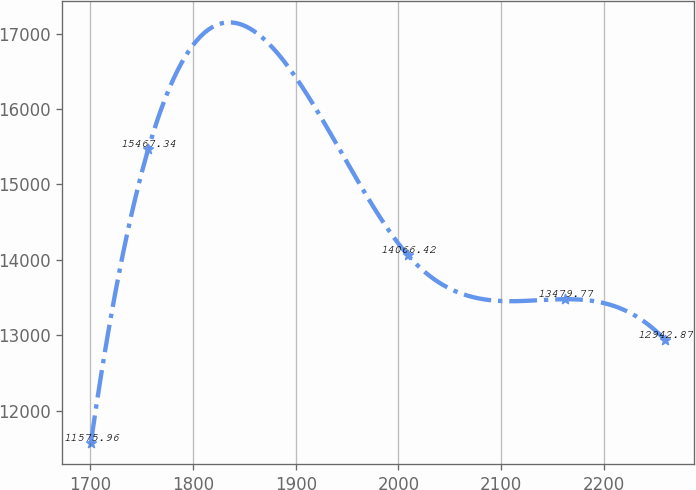Convert chart. <chart><loc_0><loc_0><loc_500><loc_500><line_chart><ecel><fcel>Unnamed: 1<nl><fcel>1700.7<fcel>11576<nl><fcel>1756.54<fcel>15467.3<nl><fcel>2008.94<fcel>14066.4<nl><fcel>2162.32<fcel>13479.8<nl><fcel>2259.13<fcel>12942.9<nl></chart> 